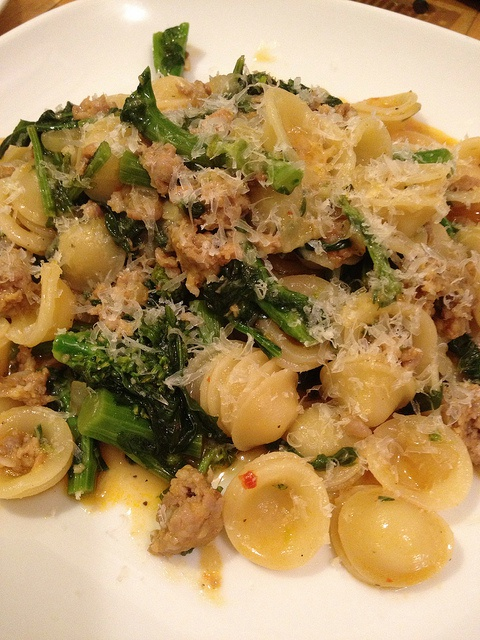Describe the objects in this image and their specific colors. I can see broccoli in ivory, black, olive, darkgreen, and maroon tones, broccoli in beige, black, olive, and tan tones, broccoli in beige, darkgreen, black, and olive tones, broccoli in beige, olive, and tan tones, and broccoli in beige, darkgreen, and olive tones in this image. 